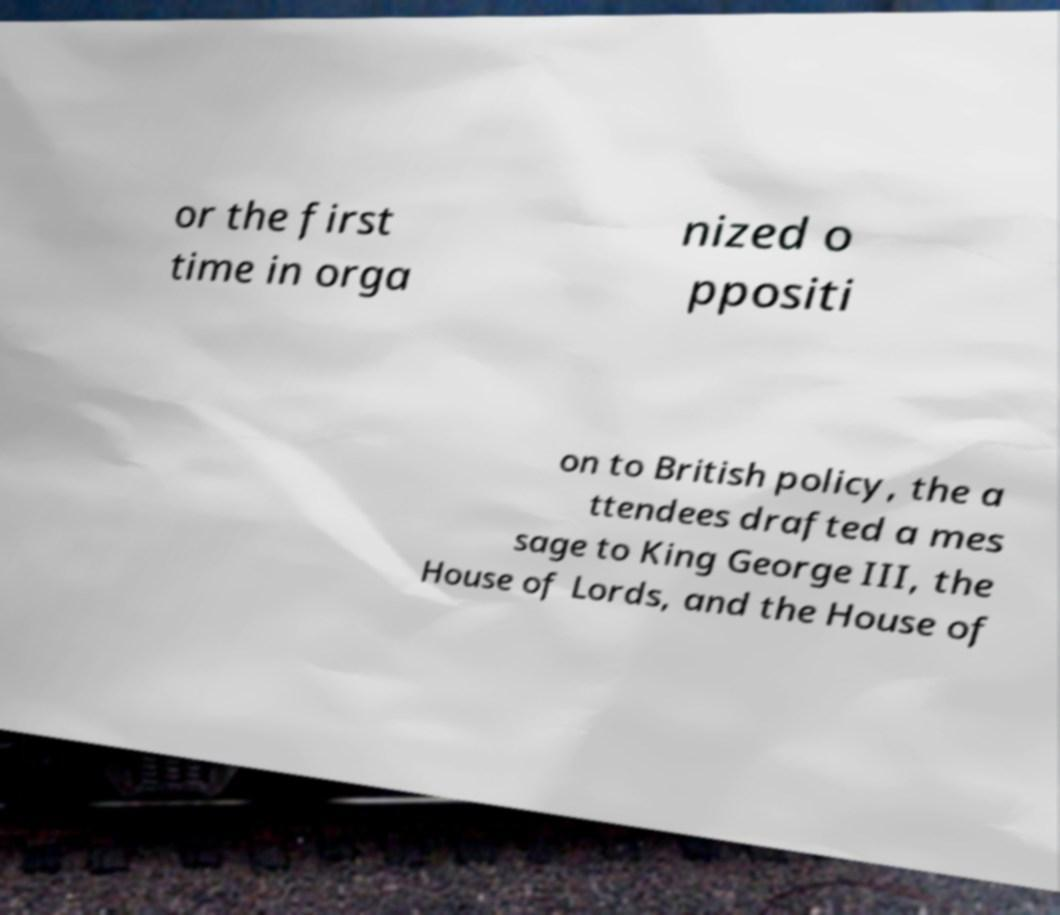There's text embedded in this image that I need extracted. Can you transcribe it verbatim? or the first time in orga nized o ppositi on to British policy, the a ttendees drafted a mes sage to King George III, the House of Lords, and the House of 